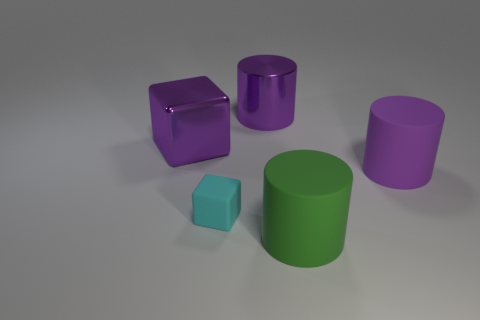There is a large shiny thing that is the same color as the metallic cylinder; what shape is it?
Provide a succinct answer. Cube. Are there any other rubber blocks that have the same color as the tiny cube?
Provide a short and direct response. No. Is the number of big purple cylinders that are to the right of the purple shiny cylinder less than the number of metallic blocks that are right of the green thing?
Provide a short and direct response. No. There is a big object that is both right of the large shiny cylinder and behind the large green matte thing; what material is it?
Give a very brief answer. Rubber. There is a small matte thing; does it have the same shape as the big rubber thing in front of the cyan thing?
Offer a very short reply. No. How many other things are the same size as the rubber cube?
Provide a short and direct response. 0. Is the number of big yellow shiny blocks greater than the number of large metallic cubes?
Ensure brevity in your answer.  No. What number of objects are both to the right of the cyan block and in front of the purple cube?
Offer a very short reply. 2. There is a big matte thing that is in front of the purple cylinder that is in front of the purple metal thing right of the small cyan block; what shape is it?
Ensure brevity in your answer.  Cylinder. Is there anything else that is the same shape as the small thing?
Make the answer very short. Yes. 